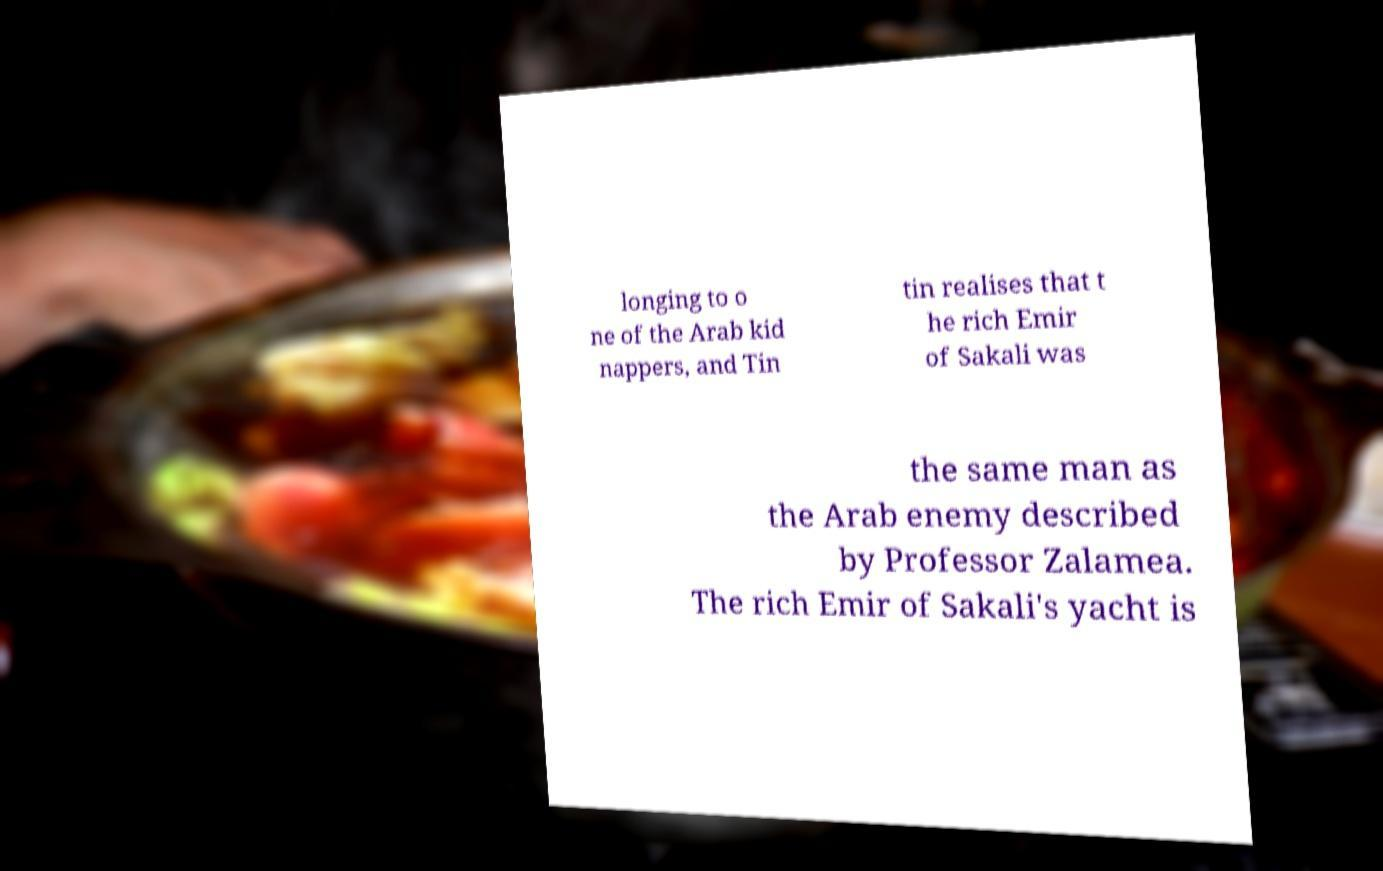Please read and relay the text visible in this image. What does it say? longing to o ne of the Arab kid nappers, and Tin tin realises that t he rich Emir of Sakali was the same man as the Arab enemy described by Professor Zalamea. The rich Emir of Sakali's yacht is 